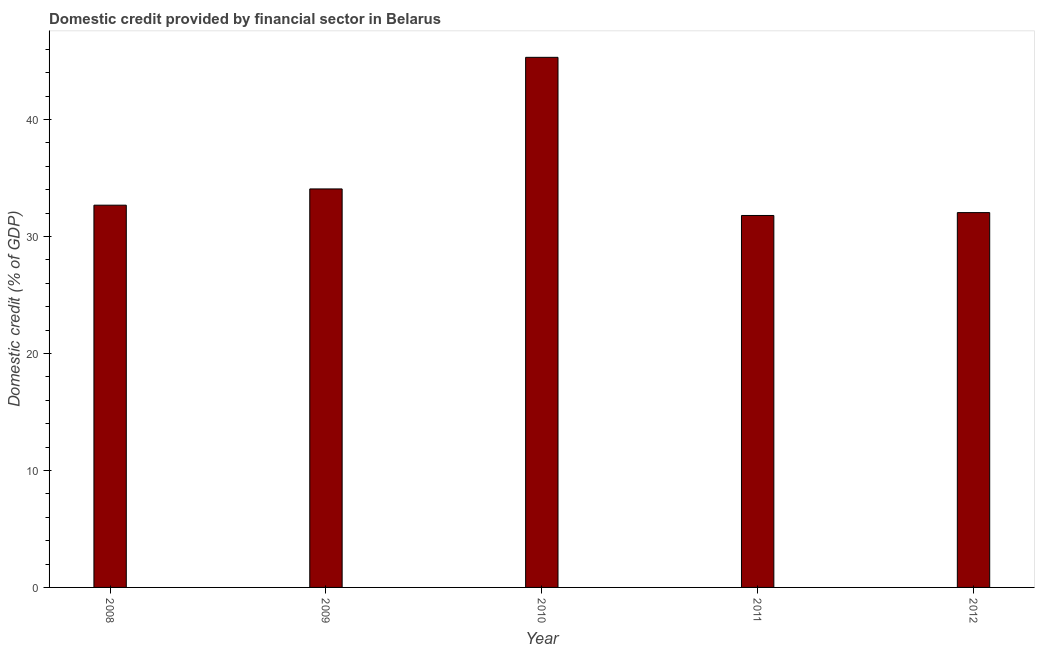What is the title of the graph?
Offer a very short reply. Domestic credit provided by financial sector in Belarus. What is the label or title of the Y-axis?
Provide a short and direct response. Domestic credit (% of GDP). What is the domestic credit provided by financial sector in 2010?
Provide a succinct answer. 45.31. Across all years, what is the maximum domestic credit provided by financial sector?
Your response must be concise. 45.31. Across all years, what is the minimum domestic credit provided by financial sector?
Offer a very short reply. 31.79. In which year was the domestic credit provided by financial sector maximum?
Provide a short and direct response. 2010. In which year was the domestic credit provided by financial sector minimum?
Offer a terse response. 2011. What is the sum of the domestic credit provided by financial sector?
Provide a short and direct response. 175.88. What is the difference between the domestic credit provided by financial sector in 2008 and 2011?
Give a very brief answer. 0.88. What is the average domestic credit provided by financial sector per year?
Offer a terse response. 35.18. What is the median domestic credit provided by financial sector?
Ensure brevity in your answer.  32.67. Do a majority of the years between 2011 and 2012 (inclusive) have domestic credit provided by financial sector greater than 34 %?
Offer a terse response. No. What is the ratio of the domestic credit provided by financial sector in 2008 to that in 2012?
Provide a short and direct response. 1.02. What is the difference between the highest and the second highest domestic credit provided by financial sector?
Your answer should be compact. 11.25. Is the sum of the domestic credit provided by financial sector in 2011 and 2012 greater than the maximum domestic credit provided by financial sector across all years?
Keep it short and to the point. Yes. What is the difference between the highest and the lowest domestic credit provided by financial sector?
Offer a terse response. 13.52. How many years are there in the graph?
Make the answer very short. 5. What is the difference between two consecutive major ticks on the Y-axis?
Make the answer very short. 10. Are the values on the major ticks of Y-axis written in scientific E-notation?
Make the answer very short. No. What is the Domestic credit (% of GDP) of 2008?
Your response must be concise. 32.67. What is the Domestic credit (% of GDP) in 2009?
Offer a very short reply. 34.06. What is the Domestic credit (% of GDP) in 2010?
Keep it short and to the point. 45.31. What is the Domestic credit (% of GDP) of 2011?
Make the answer very short. 31.79. What is the Domestic credit (% of GDP) in 2012?
Give a very brief answer. 32.04. What is the difference between the Domestic credit (% of GDP) in 2008 and 2009?
Make the answer very short. -1.39. What is the difference between the Domestic credit (% of GDP) in 2008 and 2010?
Ensure brevity in your answer.  -12.64. What is the difference between the Domestic credit (% of GDP) in 2008 and 2011?
Give a very brief answer. 0.88. What is the difference between the Domestic credit (% of GDP) in 2008 and 2012?
Offer a very short reply. 0.64. What is the difference between the Domestic credit (% of GDP) in 2009 and 2010?
Offer a very short reply. -11.25. What is the difference between the Domestic credit (% of GDP) in 2009 and 2011?
Offer a very short reply. 2.27. What is the difference between the Domestic credit (% of GDP) in 2009 and 2012?
Provide a succinct answer. 2.02. What is the difference between the Domestic credit (% of GDP) in 2010 and 2011?
Offer a terse response. 13.52. What is the difference between the Domestic credit (% of GDP) in 2010 and 2012?
Keep it short and to the point. 13.27. What is the difference between the Domestic credit (% of GDP) in 2011 and 2012?
Your response must be concise. -0.25. What is the ratio of the Domestic credit (% of GDP) in 2008 to that in 2010?
Your answer should be compact. 0.72. What is the ratio of the Domestic credit (% of GDP) in 2008 to that in 2011?
Provide a short and direct response. 1.03. What is the ratio of the Domestic credit (% of GDP) in 2009 to that in 2010?
Make the answer very short. 0.75. What is the ratio of the Domestic credit (% of GDP) in 2009 to that in 2011?
Provide a succinct answer. 1.07. What is the ratio of the Domestic credit (% of GDP) in 2009 to that in 2012?
Your response must be concise. 1.06. What is the ratio of the Domestic credit (% of GDP) in 2010 to that in 2011?
Your response must be concise. 1.43. What is the ratio of the Domestic credit (% of GDP) in 2010 to that in 2012?
Offer a very short reply. 1.41. What is the ratio of the Domestic credit (% of GDP) in 2011 to that in 2012?
Your answer should be very brief. 0.99. 